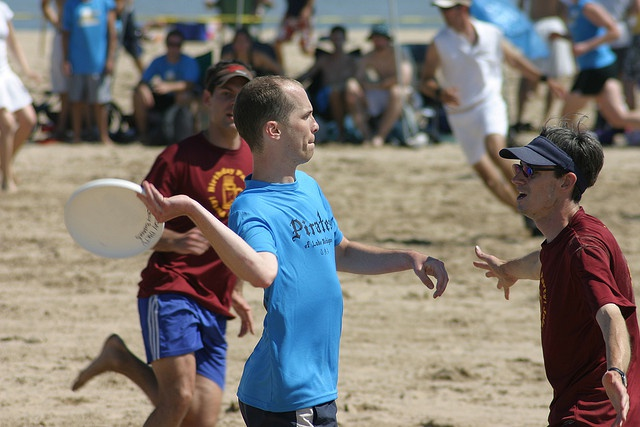Describe the objects in this image and their specific colors. I can see people in darkgray, lightblue, gray, and darkblue tones, people in darkgray, black, maroon, navy, and gray tones, people in darkgray, black, maroon, and gray tones, people in darkgray, gray, lavender, and maroon tones, and people in darkgray, darkblue, gray, and black tones in this image. 